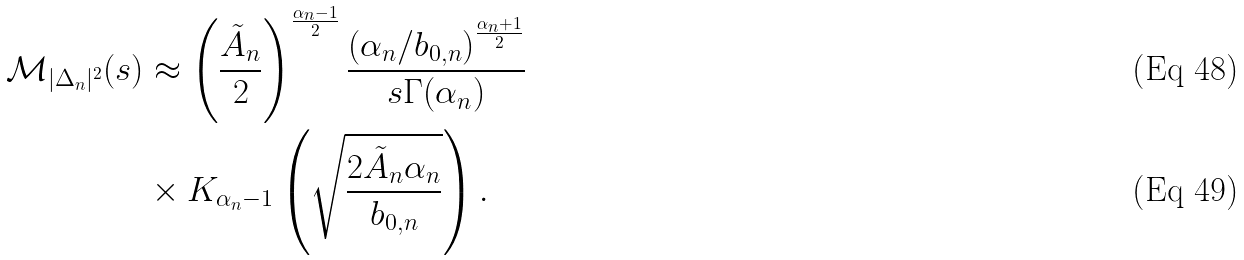Convert formula to latex. <formula><loc_0><loc_0><loc_500><loc_500>\mathcal { M } _ { | \Delta _ { n } | ^ { 2 } } ( s ) & \approx \left ( \frac { \tilde { A } _ { n } } { 2 } \right ) ^ { \frac { \alpha _ { n } - 1 } { 2 } } \frac { \left ( \alpha _ { n } / b _ { 0 , n } \right ) ^ { \frac { \alpha _ { n } + 1 } { 2 } } } { s \Gamma ( \alpha _ { n } ) } \\ & \times K _ { \alpha _ { n } - 1 } \left ( \sqrt { \frac { 2 \tilde { A } _ { n } \alpha _ { n } } { b _ { 0 , n } } } \right ) .</formula> 